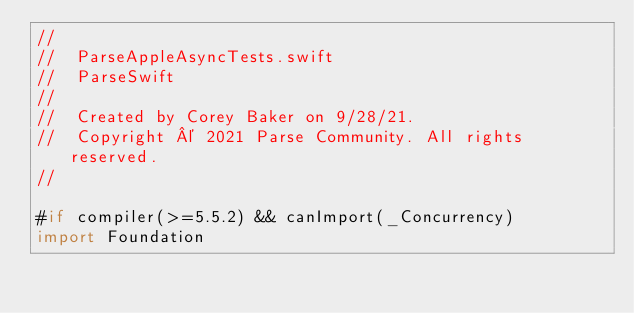Convert code to text. <code><loc_0><loc_0><loc_500><loc_500><_Swift_>//
//  ParseAppleAsyncTests.swift
//  ParseSwift
//
//  Created by Corey Baker on 9/28/21.
//  Copyright © 2021 Parse Community. All rights reserved.
//

#if compiler(>=5.5.2) && canImport(_Concurrency)
import Foundation</code> 